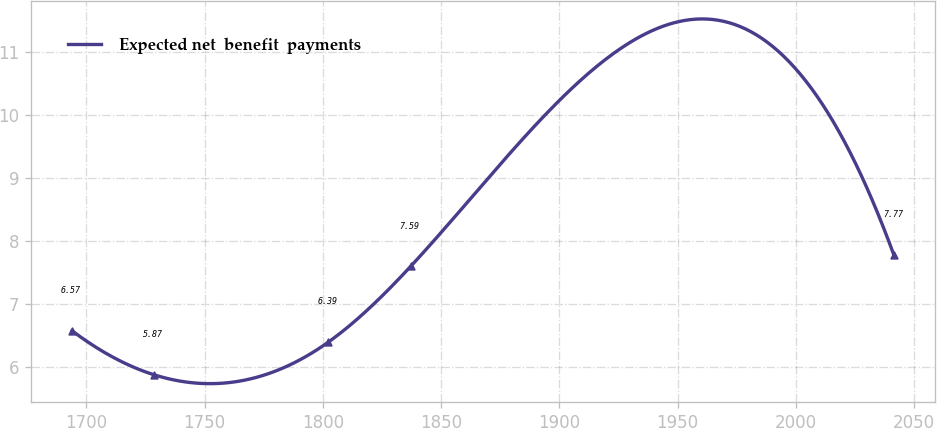Convert chart to OTSL. <chart><loc_0><loc_0><loc_500><loc_500><line_chart><ecel><fcel>Expected net  benefit  payments<nl><fcel>1693.93<fcel>6.57<nl><fcel>1728.68<fcel>5.87<nl><fcel>1802.33<fcel>6.39<nl><fcel>1837.09<fcel>7.59<nl><fcel>2041.48<fcel>7.77<nl></chart> 